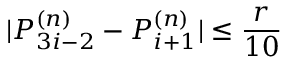Convert formula to latex. <formula><loc_0><loc_0><loc_500><loc_500>| P _ { 3 i - 2 } ^ { ( n ) } - P _ { i + 1 } ^ { ( n ) } | \leq \frac { r } { 1 0 }</formula> 